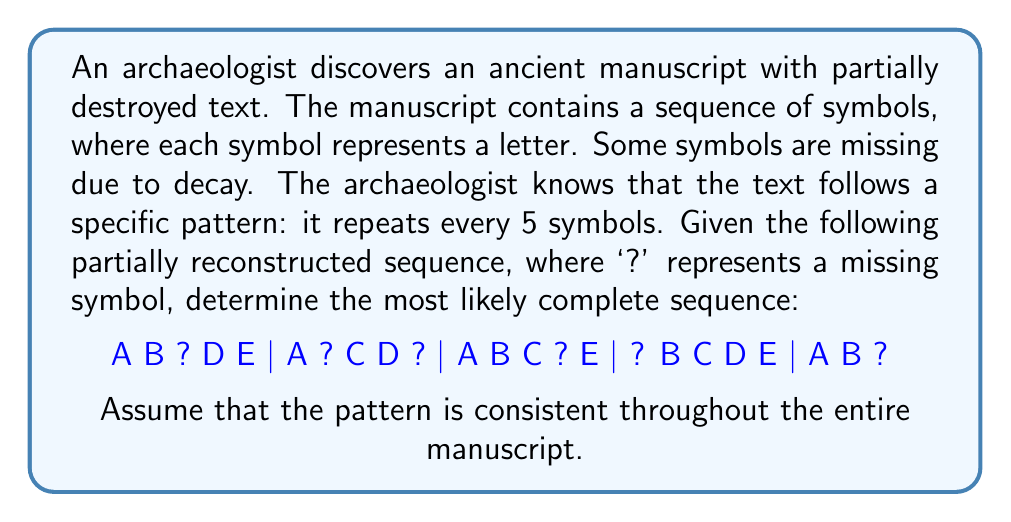Teach me how to tackle this problem. To solve this inverse problem and deduce the original text, we'll follow these steps:

1. Identify the pattern:
   The sequence repeats every 5 symbols, forming a 5x5 grid:

   $$
   \begin{matrix}
   A & B & ? & D & E \\
   A & ? & C & D & ? \\
   A & B & C & ? & E \\
   ? & B & C & D & E \\
   A & B & ? & ? & ?
   \end{matrix}
   $$

2. Analyze each column:
   Column 1: A appears 4 times, ? once
   Column 2: B appears 4 times, ? once
   Column 3: C appears 3 times, ? twice
   Column 4: D appears 3 times, ? twice
   Column 5: E appears 3 times, ? twice

3. Fill in the blanks:
   - In column 1, the missing symbol is likely A
   - In column 2, the missing symbol is likely B
   - In column 3, the two missing symbols are likely C
   - In column 4, the missing symbol is likely D
   - In column 5, the missing symbol is likely E

4. Reconstruct the complete sequence:
   A B C D E | A B C D E | A B C D E | A B C D E | A B C D E

5. Verify the reconstruction:
   The reconstructed sequence matches the given partial sequence and maintains the 5-symbol repetition pattern.
Answer: A B C D E | A B C D E | A B C D E | A B C D E | A B C D E 